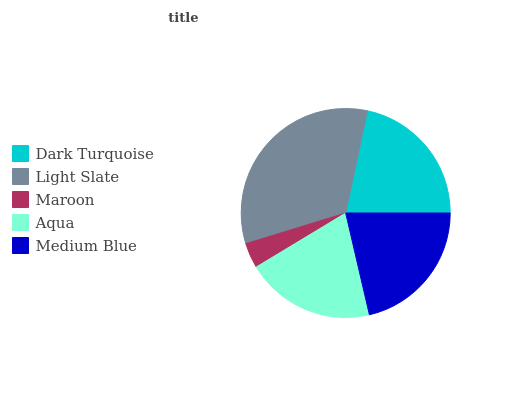Is Maroon the minimum?
Answer yes or no. Yes. Is Light Slate the maximum?
Answer yes or no. Yes. Is Light Slate the minimum?
Answer yes or no. No. Is Maroon the maximum?
Answer yes or no. No. Is Light Slate greater than Maroon?
Answer yes or no. Yes. Is Maroon less than Light Slate?
Answer yes or no. Yes. Is Maroon greater than Light Slate?
Answer yes or no. No. Is Light Slate less than Maroon?
Answer yes or no. No. Is Medium Blue the high median?
Answer yes or no. Yes. Is Medium Blue the low median?
Answer yes or no. Yes. Is Aqua the high median?
Answer yes or no. No. Is Dark Turquoise the low median?
Answer yes or no. No. 